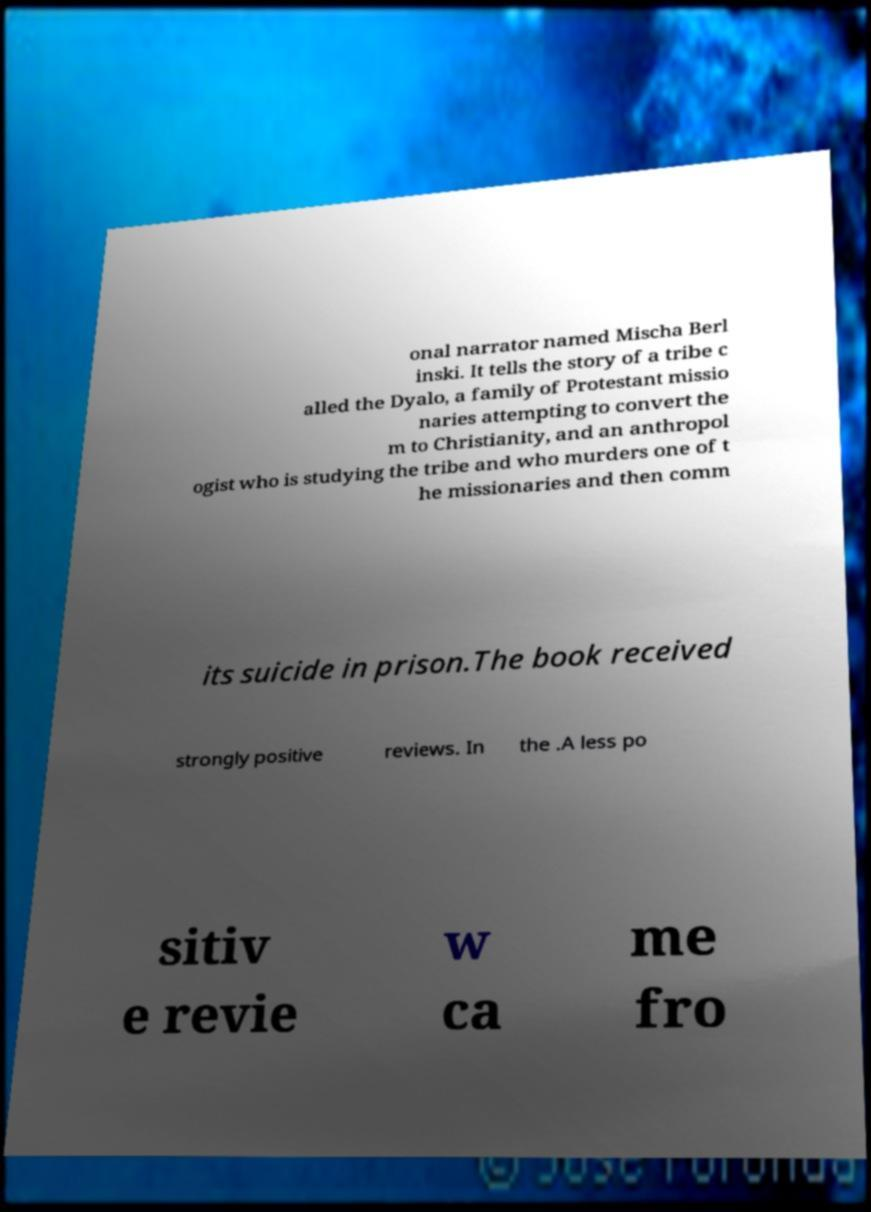For documentation purposes, I need the text within this image transcribed. Could you provide that? onal narrator named Mischa Berl inski. It tells the story of a tribe c alled the Dyalo, a family of Protestant missio naries attempting to convert the m to Christianity, and an anthropol ogist who is studying the tribe and who murders one of t he missionaries and then comm its suicide in prison.The book received strongly positive reviews. In the .A less po sitiv e revie w ca me fro 